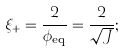Convert formula to latex. <formula><loc_0><loc_0><loc_500><loc_500>\xi _ { + } = \frac { 2 } { \phi _ { \text {eq} } } = \frac { 2 } { \sqrt { J } } ;</formula> 